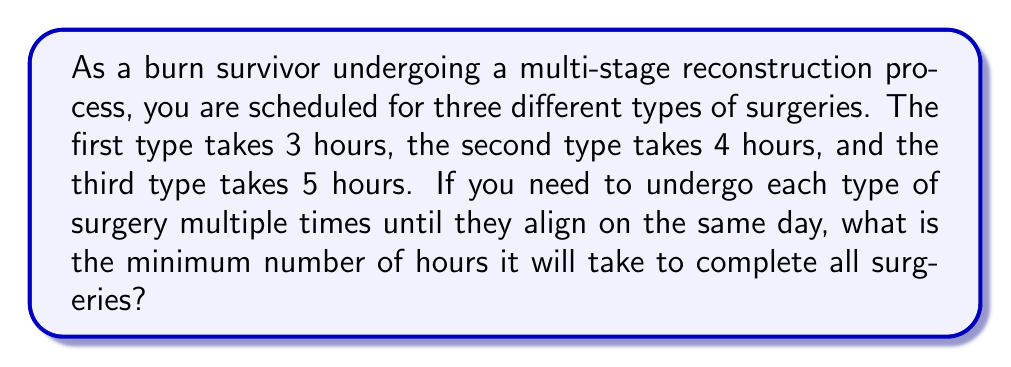Can you answer this question? To solve this problem, we need to find the least common multiple (LCM) of the surgery durations: 3, 4, and 5 hours.

Step 1: Prime factorization of the numbers
$3 = 3$
$4 = 2^2$
$5 = 5$

Step 2: Identify the highest power of each prime factor
$2^2 = 4$
$3^1 = 3$
$5^1 = 5$

Step 3: Multiply the highest powers of each prime factor
$LCM = 2^2 \times 3 \times 5$

Step 4: Calculate the result
$LCM = 4 \times 3 \times 5 = 60$

Therefore, the least common multiple of 3, 4, and 5 is 60 hours.

This means that after 60 hours, all three types of surgeries will align on the same day. Specifically:
- The 3-hour surgery will have been performed 20 times (60 ÷ 3 = 20)
- The 4-hour surgery will have been performed 15 times (60 ÷ 4 = 15)
- The 5-hour surgery will have been performed 12 times (60 ÷ 5 = 12)
Answer: The minimum number of hours it will take to complete all surgeries is 60 hours. 